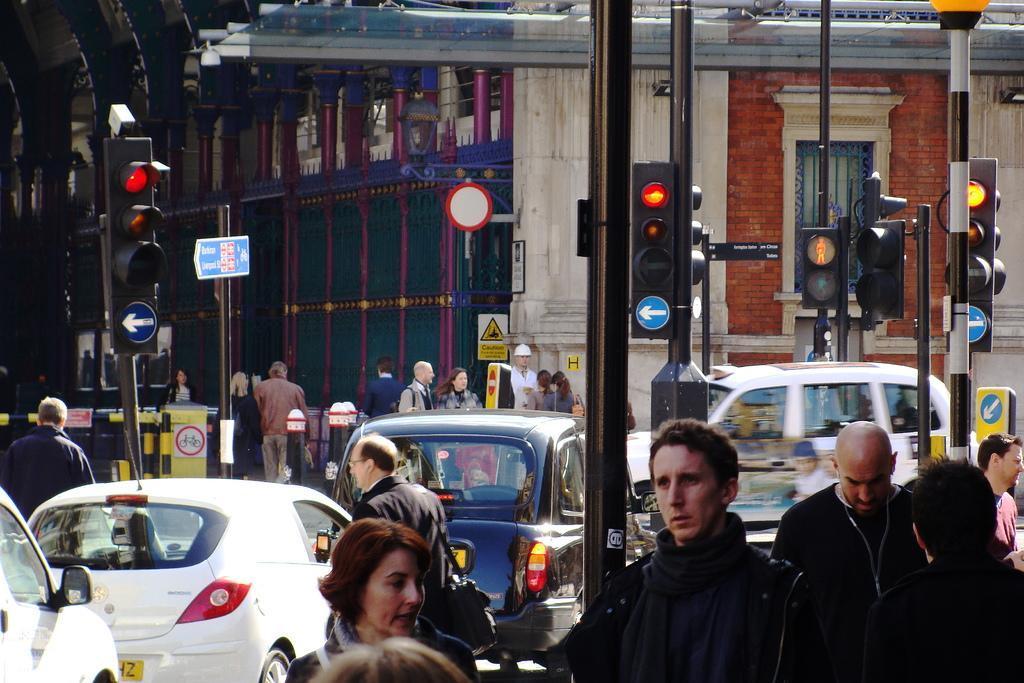How would you summarize this image in a sentence or two? In this picture I can observe some people. There are poles to which traffic signals are fixed in this picture. I can observe some cars moving on the road. In the background there is a building. 